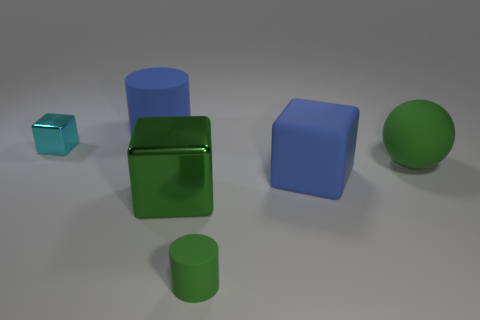There is a small object that is behind the block that is to the right of the tiny green cylinder; what is its material?
Your answer should be very brief. Metal. How many big objects have the same color as the big cylinder?
Ensure brevity in your answer.  1. Are there fewer big spheres to the left of the small matte thing than cyan rubber spheres?
Offer a terse response. No. The rubber cylinder in front of the blue object that is behind the tiny cyan thing is what color?
Your answer should be compact. Green. What is the size of the cylinder that is in front of the large matte thing that is left of the blue thing that is on the right side of the green cylinder?
Your answer should be very brief. Small. Are there fewer tiny cyan shiny objects that are in front of the matte block than blue matte things behind the green matte sphere?
Your answer should be very brief. Yes. How many green things have the same material as the big green block?
Offer a terse response. 0. There is a shiny block that is in front of the green rubber object behind the small matte object; is there a large blue thing that is left of it?
Your response must be concise. Yes. There is a small object that is made of the same material as the blue cube; what is its shape?
Keep it short and to the point. Cylinder. Is the number of green metallic cubes greater than the number of large blue metal objects?
Your answer should be very brief. Yes. 